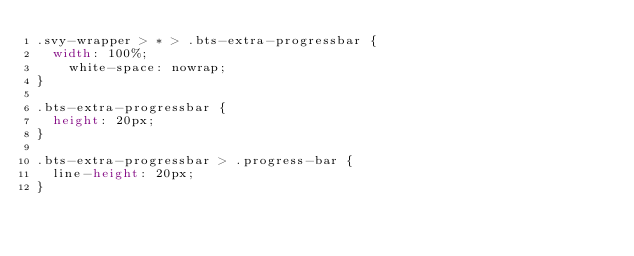<code> <loc_0><loc_0><loc_500><loc_500><_CSS_>.svy-wrapper > * > .bts-extra-progressbar {
	width: 100%;
    white-space: nowrap;
}

.bts-extra-progressbar {
	height: 20px;
}

.bts-extra-progressbar > .progress-bar {
	line-height: 20px;
}</code> 